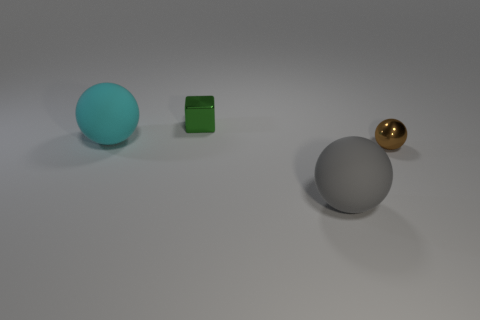Are there more small metal things that are in front of the cyan matte ball than large cyan balls that are on the right side of the big gray rubber object? Yes, there are more small metal things in front of the cyan matte ball (two small metal cubes) than there are large cyan balls to the right of the big gray rubber object (there are none). The image shows a clear view with the cyan ball, two small metal cubes, a large gray rubber ball, and a golden ball, helping to identify the objects in question accurately. 